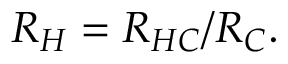Convert formula to latex. <formula><loc_0><loc_0><loc_500><loc_500>R _ { H } = R _ { H C } / R _ { C } .</formula> 